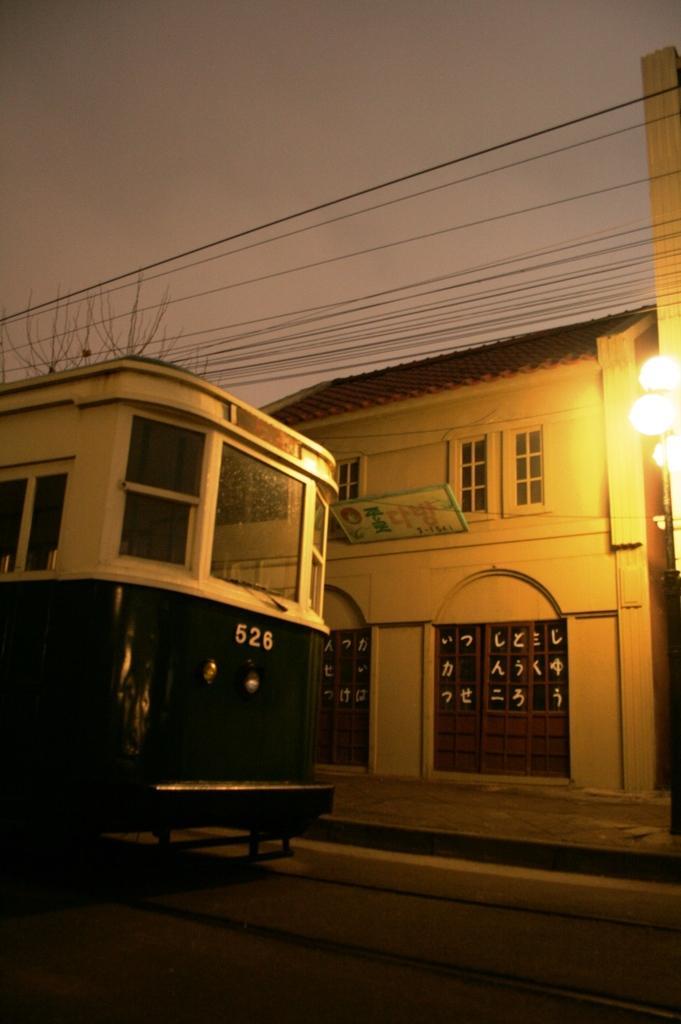Could you give a brief overview of what you see in this image? In this picture we can see a bus in the front, in the background there is a house and a board, on the right side we can see lights, there are some wires in the middle, we can see the sky at the top of the picture. 